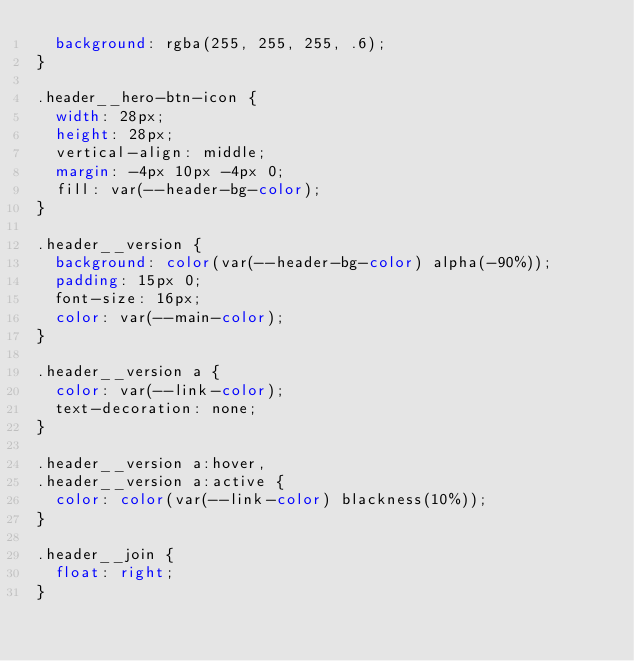Convert code to text. <code><loc_0><loc_0><loc_500><loc_500><_CSS_>  background: rgba(255, 255, 255, .6);
}

.header__hero-btn-icon {
  width: 28px;
  height: 28px;
  vertical-align: middle;
  margin: -4px 10px -4px 0;
  fill: var(--header-bg-color);
}

.header__version {
  background: color(var(--header-bg-color) alpha(-90%));
  padding: 15px 0;
  font-size: 16px;
  color: var(--main-color);
}

.header__version a {
  color: var(--link-color);
  text-decoration: none;
}

.header__version a:hover,
.header__version a:active {
  color: color(var(--link-color) blackness(10%));
}

.header__join {
  float: right;
}
</code> 